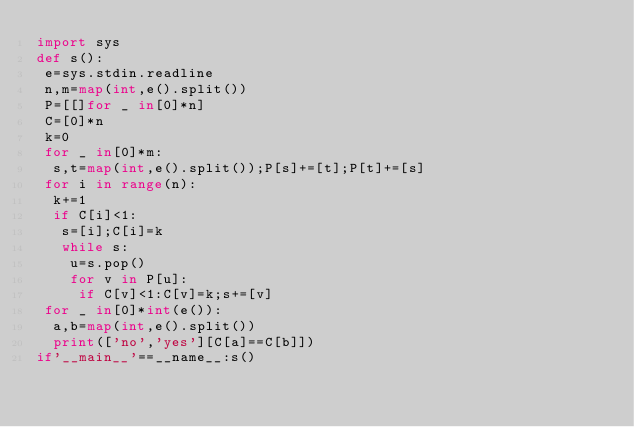<code> <loc_0><loc_0><loc_500><loc_500><_Python_>import sys
def s():
 e=sys.stdin.readline
 n,m=map(int,e().split())
 P=[[]for _ in[0]*n]
 C=[0]*n
 k=0
 for _ in[0]*m:
  s,t=map(int,e().split());P[s]+=[t];P[t]+=[s]
 for i in range(n):
  k+=1
  if C[i]<1:
   s=[i];C[i]=k
   while s:
    u=s.pop()
    for v in P[u]:
     if C[v]<1:C[v]=k;s+=[v]
 for _ in[0]*int(e()):
  a,b=map(int,e().split())
  print(['no','yes'][C[a]==C[b]])
if'__main__'==__name__:s()
</code> 